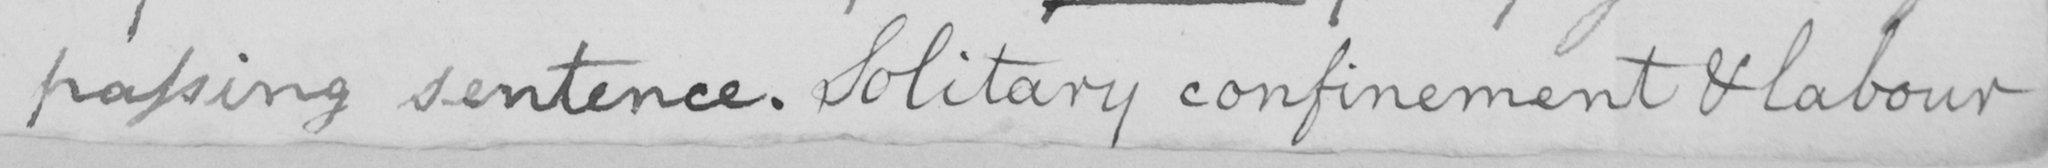Please provide the text content of this handwritten line. passing sentence. Solitary confinement & labour 